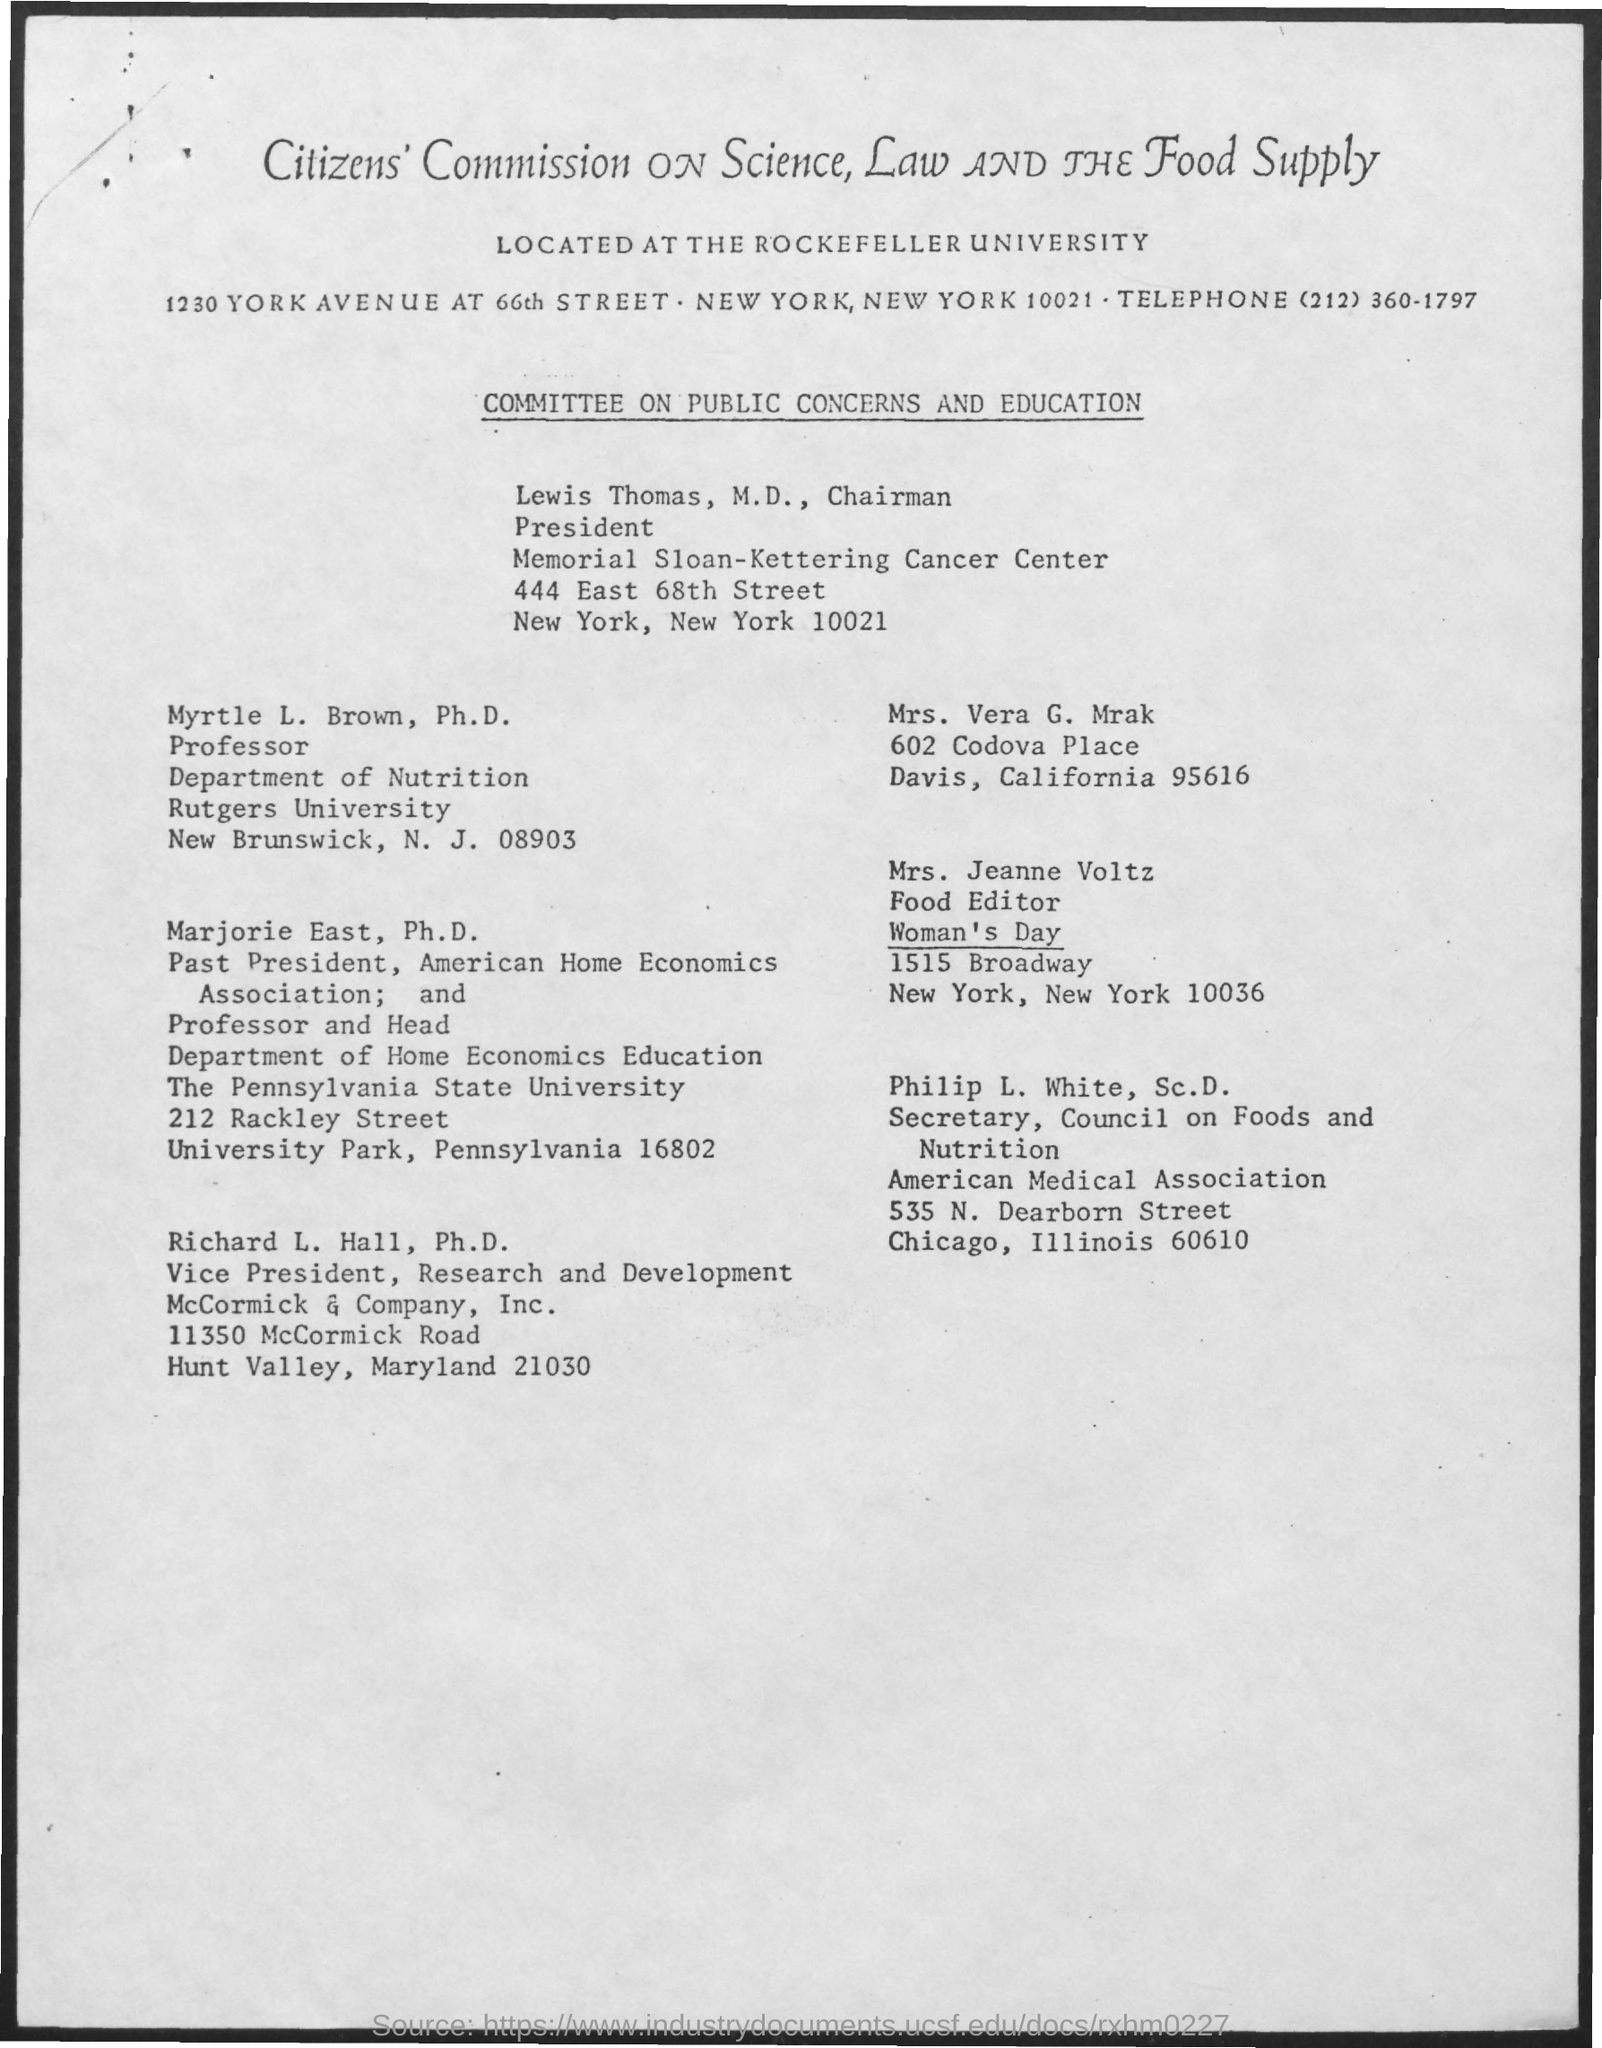Identify some key points in this picture. Myrtle L. Brown belongs to the Department of Nutrition. The telephone number mentioned in the given page is (212) 360-1797. Mrytle L. Brown belongs to Rutgers University. 